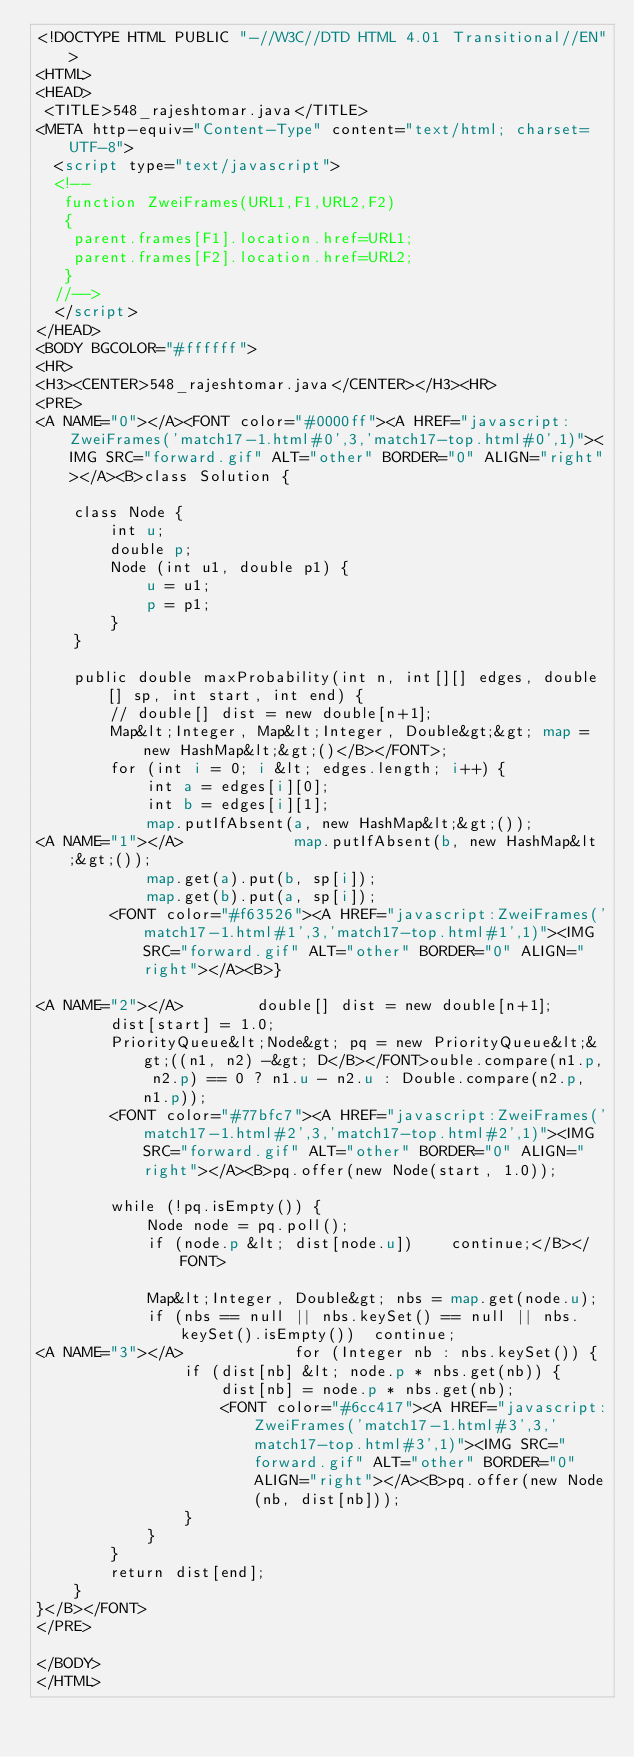<code> <loc_0><loc_0><loc_500><loc_500><_HTML_><!DOCTYPE HTML PUBLIC "-//W3C//DTD HTML 4.01 Transitional//EN">
<HTML>
<HEAD>
 <TITLE>548_rajeshtomar.java</TITLE>
<META http-equiv="Content-Type" content="text/html; charset=UTF-8">
  <script type="text/javascript">
  <!--
   function ZweiFrames(URL1,F1,URL2,F2)
   {
    parent.frames[F1].location.href=URL1;
    parent.frames[F2].location.href=URL2;
   }
  //-->
  </script>
</HEAD>
<BODY BGCOLOR="#ffffff">
<HR>
<H3><CENTER>548_rajeshtomar.java</CENTER></H3><HR>
<PRE>
<A NAME="0"></A><FONT color="#0000ff"><A HREF="javascript:ZweiFrames('match17-1.html#0',3,'match17-top.html#0',1)"><IMG SRC="forward.gif" ALT="other" BORDER="0" ALIGN="right"></A><B>class Solution {
    
    class Node {
        int u;
        double p;
        Node (int u1, double p1) {
            u = u1;
            p = p1;
        }
    }
    
    public double maxProbability(int n, int[][] edges, double[] sp, int start, int end) {
        // double[] dist = new double[n+1];
        Map&lt;Integer, Map&lt;Integer, Double&gt;&gt; map = new HashMap&lt;&gt;()</B></FONT>;
        for (int i = 0; i &lt; edges.length; i++) {
            int a = edges[i][0];
            int b = edges[i][1];            
            map.putIfAbsent(a, new HashMap&lt;&gt;());
<A NAME="1"></A>            map.putIfAbsent(b, new HashMap&lt;&gt;());
            map.get(a).put(b, sp[i]);
            map.get(b).put(a, sp[i]);
        <FONT color="#f63526"><A HREF="javascript:ZweiFrames('match17-1.html#1',3,'match17-top.html#1',1)"><IMG SRC="forward.gif" ALT="other" BORDER="0" ALIGN="right"></A><B>}
        
<A NAME="2"></A>        double[] dist = new double[n+1];
        dist[start] = 1.0;
        PriorityQueue&lt;Node&gt; pq = new PriorityQueue&lt;&gt;((n1, n2) -&gt; D</B></FONT>ouble.compare(n1.p, n2.p) == 0 ? n1.u - n2.u : Double.compare(n2.p, n1.p));
        <FONT color="#77bfc7"><A HREF="javascript:ZweiFrames('match17-1.html#2',3,'match17-top.html#2',1)"><IMG SRC="forward.gif" ALT="other" BORDER="0" ALIGN="right"></A><B>pq.offer(new Node(start, 1.0));
        
        while (!pq.isEmpty()) {
            Node node = pq.poll();
            if (node.p &lt; dist[node.u])    continue;</B></FONT>
            
            Map&lt;Integer, Double&gt; nbs = map.get(node.u);
            if (nbs == null || nbs.keySet() == null || nbs.keySet().isEmpty())  continue;
<A NAME="3"></A>            for (Integer nb : nbs.keySet()) {
                if (dist[nb] &lt; node.p * nbs.get(nb)) {
                    dist[nb] = node.p * nbs.get(nb);
                    <FONT color="#6cc417"><A HREF="javascript:ZweiFrames('match17-1.html#3',3,'match17-top.html#3',1)"><IMG SRC="forward.gif" ALT="other" BORDER="0" ALIGN="right"></A><B>pq.offer(new Node(nb, dist[nb]));
                }
            }
        }
        return dist[end];
    }
}</B></FONT>
</PRE>

</BODY>
</HTML>
</code> 